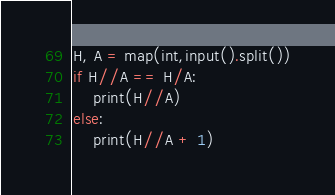Convert code to text. <code><loc_0><loc_0><loc_500><loc_500><_Python_>H, A = map(int,input().split())
if H//A == H/A:
    print(H//A)
else:
    print(H//A + 1)</code> 